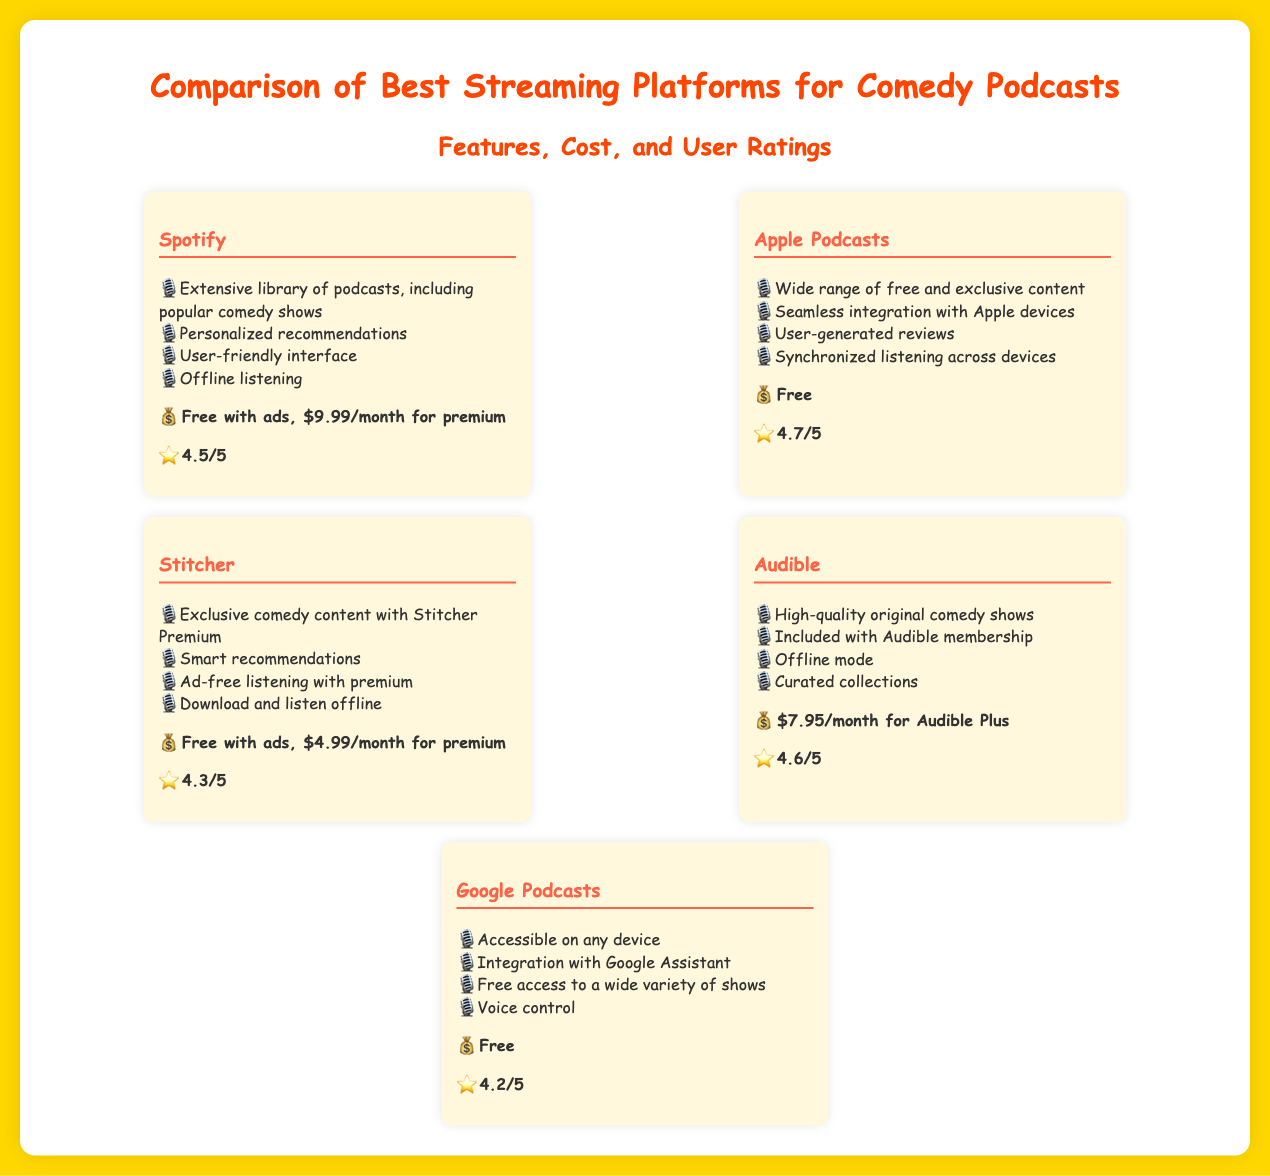What is the cost of Spotify Premium? The cost of Spotify Premium is mentioned in the document as $9.99/month.
Answer: $9.99/month Which platform has the highest user rating? The user ratings for all platforms are listed, and Apple Podcasts has the highest rating at 4.7/5.
Answer: 4.7/5 What feature does Stitcher Premium offer? One of the features listed for Stitcher is exclusive comedy content with Stitcher Premium.
Answer: Exclusive comedy content Which platform offers free access to childhood podcasts? The document states that Google Podcasts offers free access to a wide variety of shows, which includes childhood podcasts.
Answer: Google Podcasts What is the monthly cost of Audible Plus? The document specifies the monthly cost of Audible Plus as $7.95/month.
Answer: $7.95/month Which streaming platform is specifically highlighted for offline listening? Multiple platforms are noted for offline listening, but Spotify explicitly lists it as one of its features.
Answer: Spotify What type of integration does Apple Podcasts provide? Apple Podcasts is noted for seamless integration with Apple devices in the features section.
Answer: Seamless integration with Apple devices What type of content can users expect from Audible? The document highlights that Audible has high-quality original comedy shows as part of its offerings.
Answer: High-quality original comedy shows 